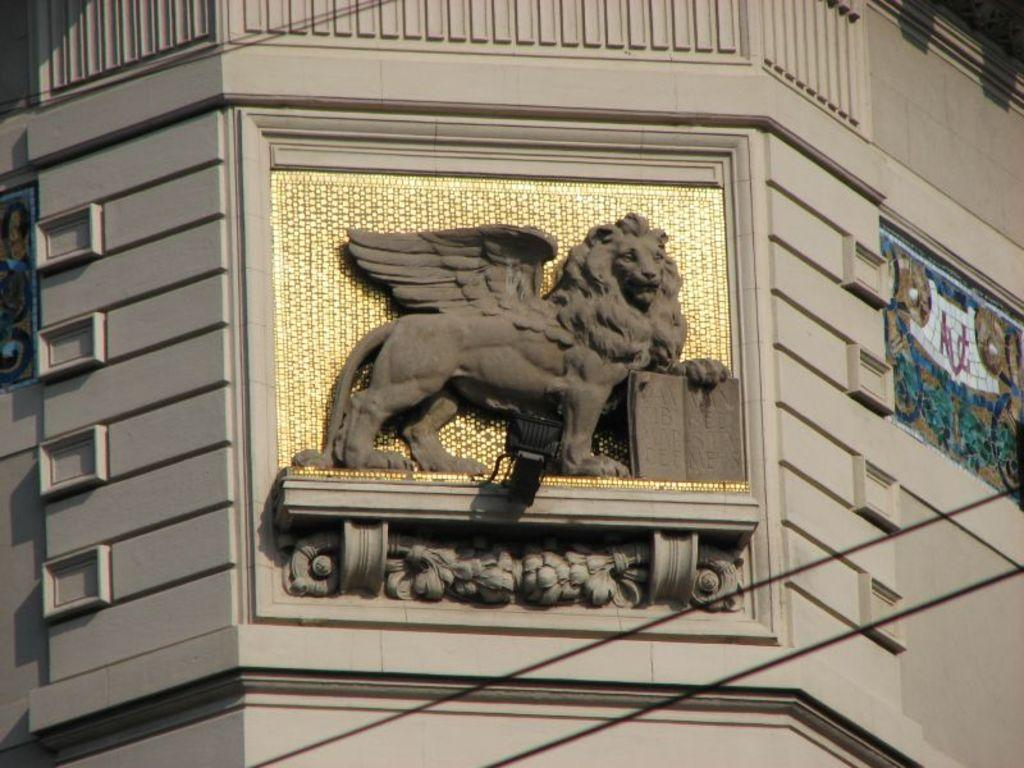What can be seen in the center of the image? There is a carving on the wall in the center of the image. What is located in the background of the image? There is a painting and a wall visible in the background of the image. How many boats are visible in the image? There are no boats present in the image. 